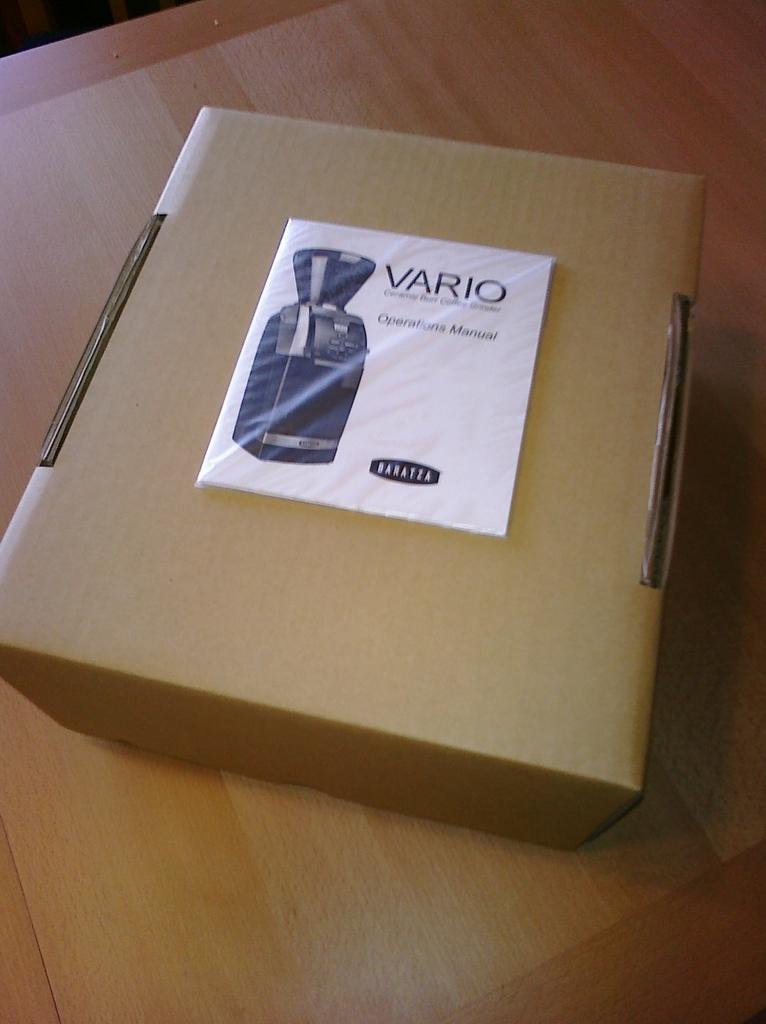Provide a one-sentence caption for the provided image. A cardboard box with a Vario operations manual on top of it. 